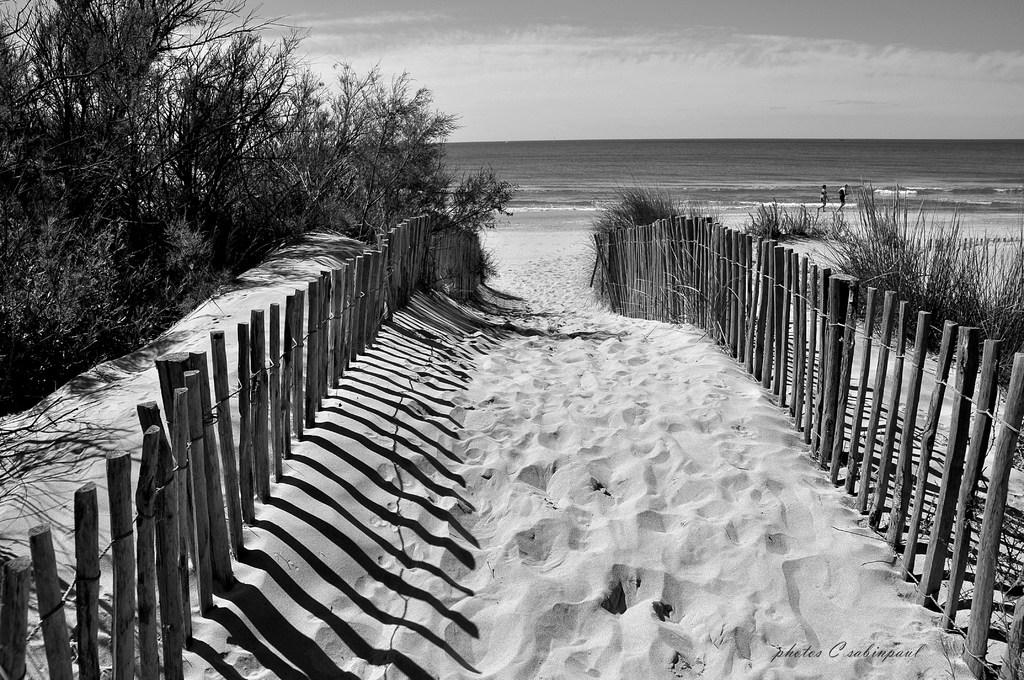What type of fencing is in the image? There is a wooden fencing in the image. What is the ground made of in the image? Sand is visible in the image. What type of vegetation is present in the image? There are trees in the image. What are the two people in the image doing? They are walking in the image. What natural element is present in the image? Water is present in the image. What is the color scheme of the image? The image is in black and white. How many frogs can be seen hopping on the wooden fencing in the image? There are no frogs present in the image. What type of balls are being used by the two people walking in the image? There are no balls visible in the image; the two people are simply walking. 